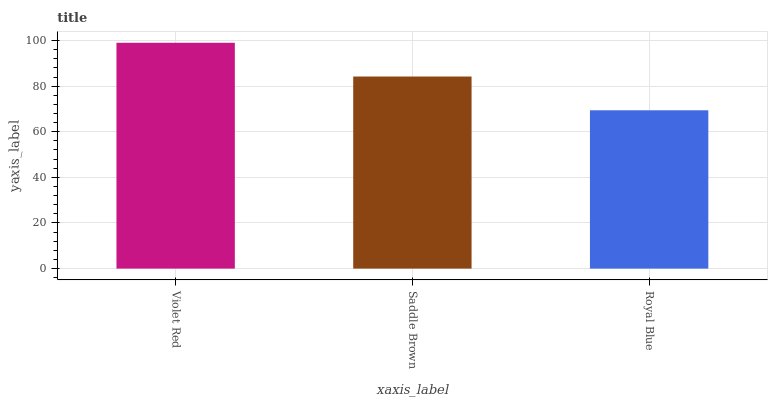Is Royal Blue the minimum?
Answer yes or no. Yes. Is Violet Red the maximum?
Answer yes or no. Yes. Is Saddle Brown the minimum?
Answer yes or no. No. Is Saddle Brown the maximum?
Answer yes or no. No. Is Violet Red greater than Saddle Brown?
Answer yes or no. Yes. Is Saddle Brown less than Violet Red?
Answer yes or no. Yes. Is Saddle Brown greater than Violet Red?
Answer yes or no. No. Is Violet Red less than Saddle Brown?
Answer yes or no. No. Is Saddle Brown the high median?
Answer yes or no. Yes. Is Saddle Brown the low median?
Answer yes or no. Yes. Is Violet Red the high median?
Answer yes or no. No. Is Violet Red the low median?
Answer yes or no. No. 